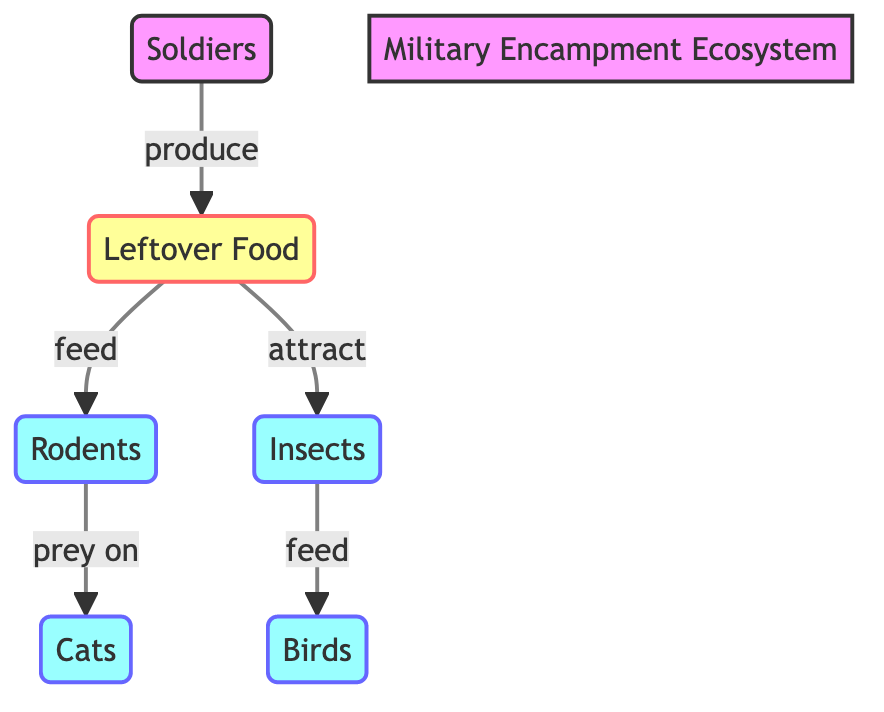What animal preys on rodents? The diagram shows an arrow connecting rodents to cats, indicating that cats prey on rodents. This means that cats are the animals that benefit from hunting rodents.
Answer: Cats How many types of animals are in the diagram? By counting the nodes labeled as animals—rodents, cats, insects, and birds—we find there are four distinct types of animals represented.
Answer: 4 What do soldiers produce? The diagram shows an arrow from soldiers to leftover food, indicating that the output or "production" effect of soldiers is leftover food.
Answer: Leftover Food What do insects feed on? The diagram indicates that there is an arrow from leftover food to insects, showing that insects are attracted to and feed on the leftover food produced by soldiers.
Answer: Leftover Food Which animals are fed by leftover food? The diagram shows arrows going from leftover food to both rodents and insects. This indicates that both of these animal types are nourished by the leftover food from soldiers.
Answer: Rodents and Insects Which animal is directly affected by insects? The diagram presents an arrow indicating that insects feed birds, meaning that birds are directly affected by the presence of insects in the ecosystem.
Answer: Birds How many feeding relationships does leftover food have? Based on the diagram, leftover food has two outgoing relationships: one to rodents and one to insects. Therefore, it has two feeding relationships.
Answer: 2 What is the role of cats in this ecosystem? The diagram shows that cats prey on rodents, placing them in a predatory position over this specific group of animals within the military encampment ecosystem.
Answer: Predators 